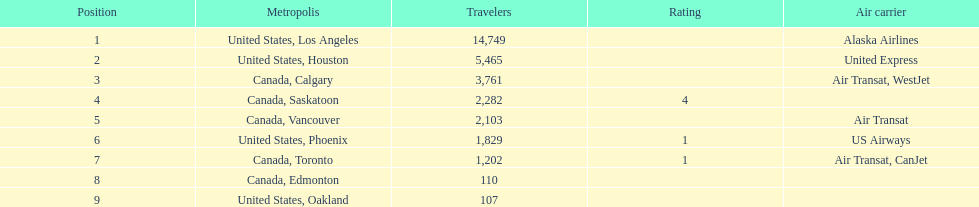What was the number of passengers in phoenix arizona? 1,829. 